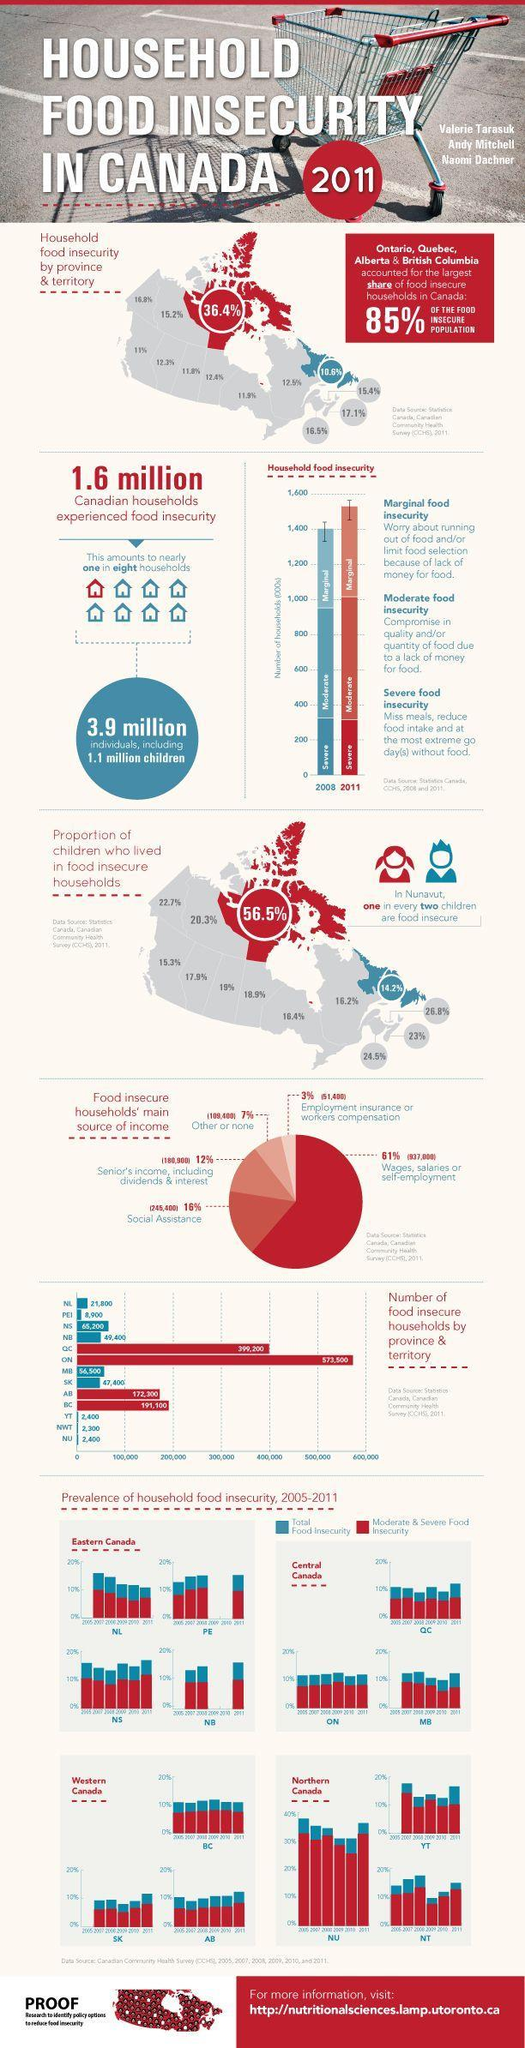Which is the province has the least percentage of food insecurity, Quebec, Ontario, New Foundland & Labrador?
Answer the question with a short phrase. New Foundland & Labrador How many provinces in Canada accounted for the largest households with food insecurity? 4 